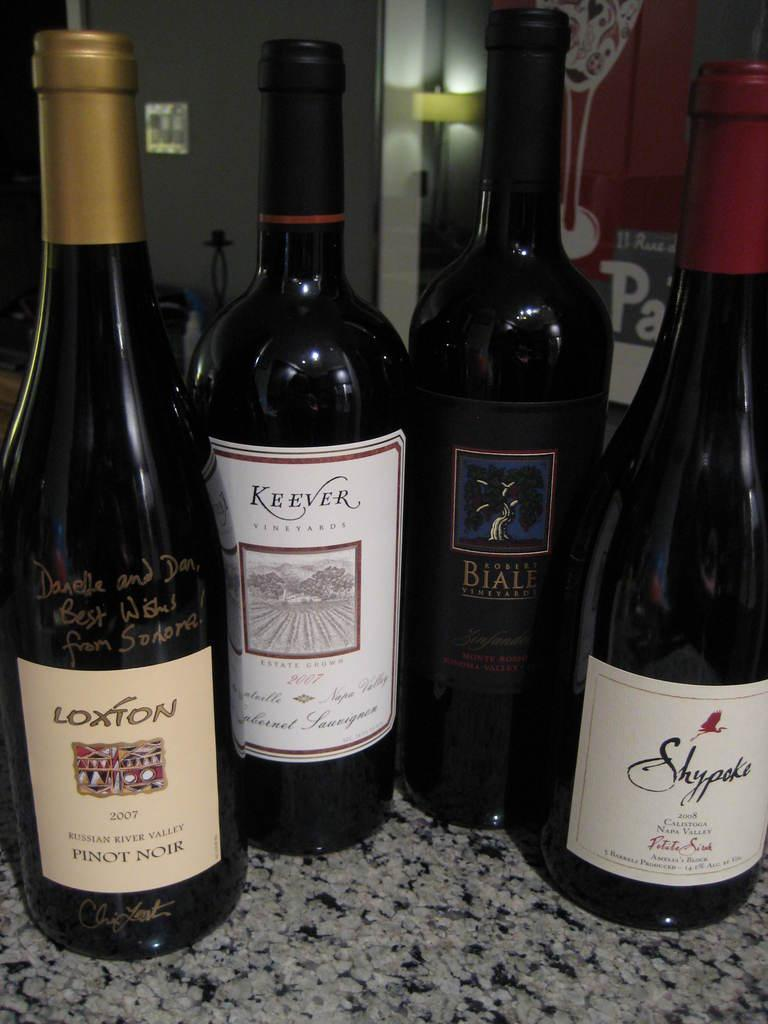<image>
Describe the image concisely. Bottles of various wines, including Keever, are on a marble surface. 